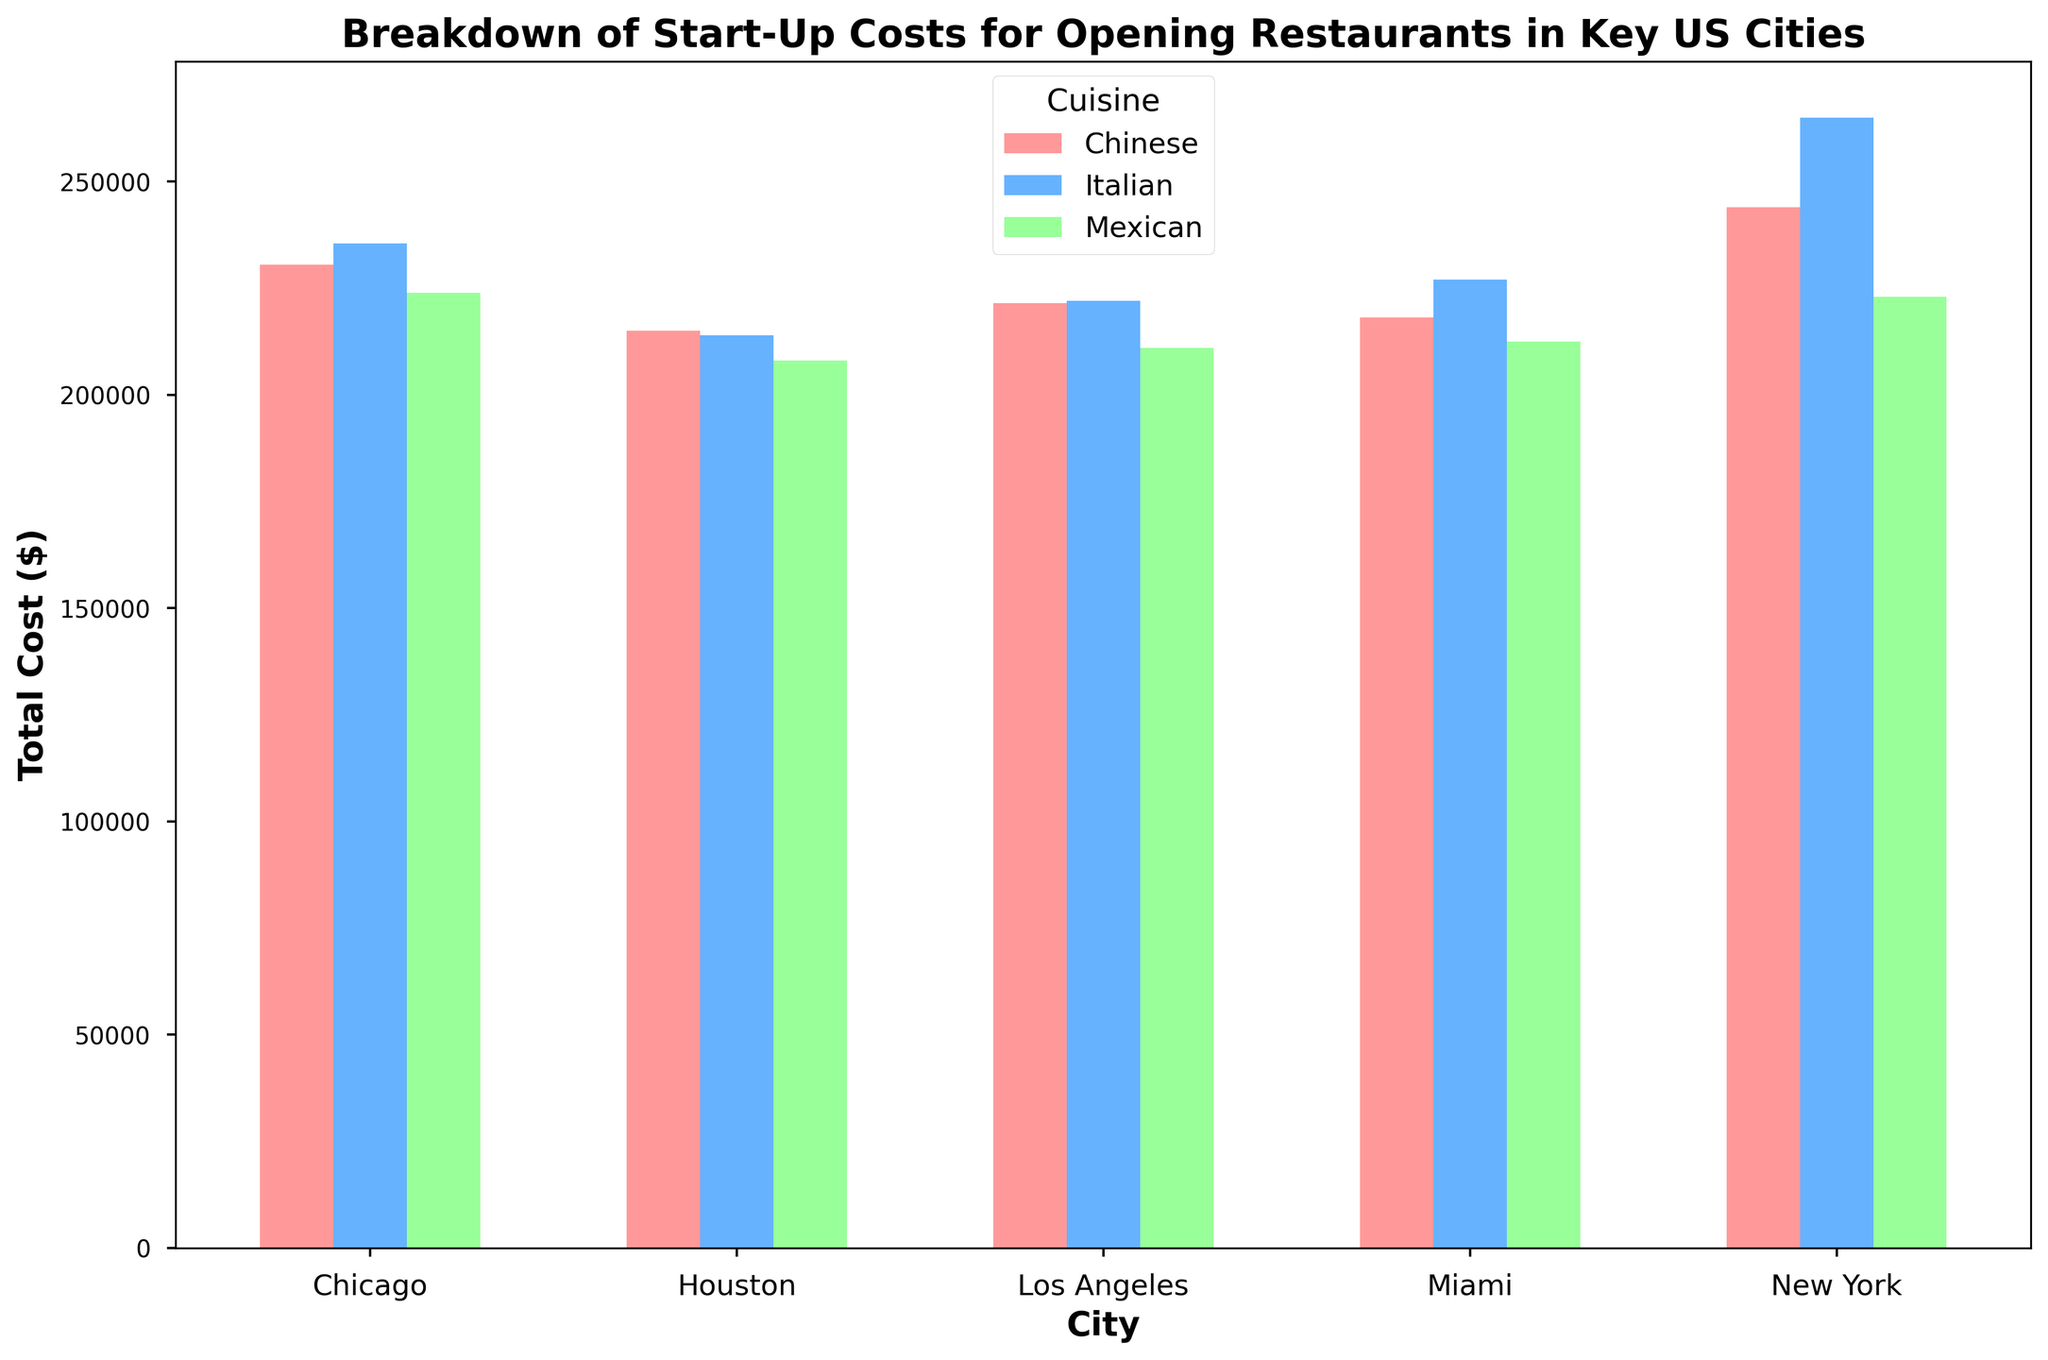Which city has the highest start-up cost for Italian cuisine? By examining the height of the bars for Italian cuisine, we see that New York has the highest bar among all cities for Italian cuisine, indicating it has the highest start-up cost.
Answer: New York Which cuisine in Los Angeles has the lowest total start-up cost? By comparing the bars for each cuisine in Los Angeles, we find that the bar for Mexican cuisine is the shortest, indicating it has the lowest total start-up cost.
Answer: Mexican What is the difference in total start-up costs between Italian and Chinese cuisine in New York? Subtract the total start-up cost for Chinese cuisine from the total start-up cost for Italian cuisine in New York: 265,000 - 244,000.
Answer: 21,000 Which city has the smallest variation in start-up costs among the three cuisines? By observing the length of the bars within each city, Houston has the least variation in bar heights, indicating the smallest variation in start-up costs.
Answer: Houston On average, which cuisine has the highest start-up cost across all cities? Sum the total start-up costs for each cuisine across all cities and divide by the number of cities (5). Calculate and compare the averages for Italian, Mexican, and Chinese cuisines.
Answer: Italian Is there any city where the start-up costs for Mexican and Chinese cuisines are equal? By comparing the bar heights for Mexican and Chinese cuisines in each city, no cities have exactly equal bar heights for these two cuisines' start-up costs.
Answer: No Which cuisine shows the most consistent start-up cost across different cities? By analyzing the bars' heights, we see that Chinese cuisine has bars that are more consistent in height across different cities compared to Italian and Mexican cuisines.
Answer: Chinese How much more does it cost to open an Italian restaurant in Chicago compared to Houston? Subtract the total start-up cost for Italian cuisine in Houston from that in Chicago: 235,500 - 214,000.
Answer: 21,500 